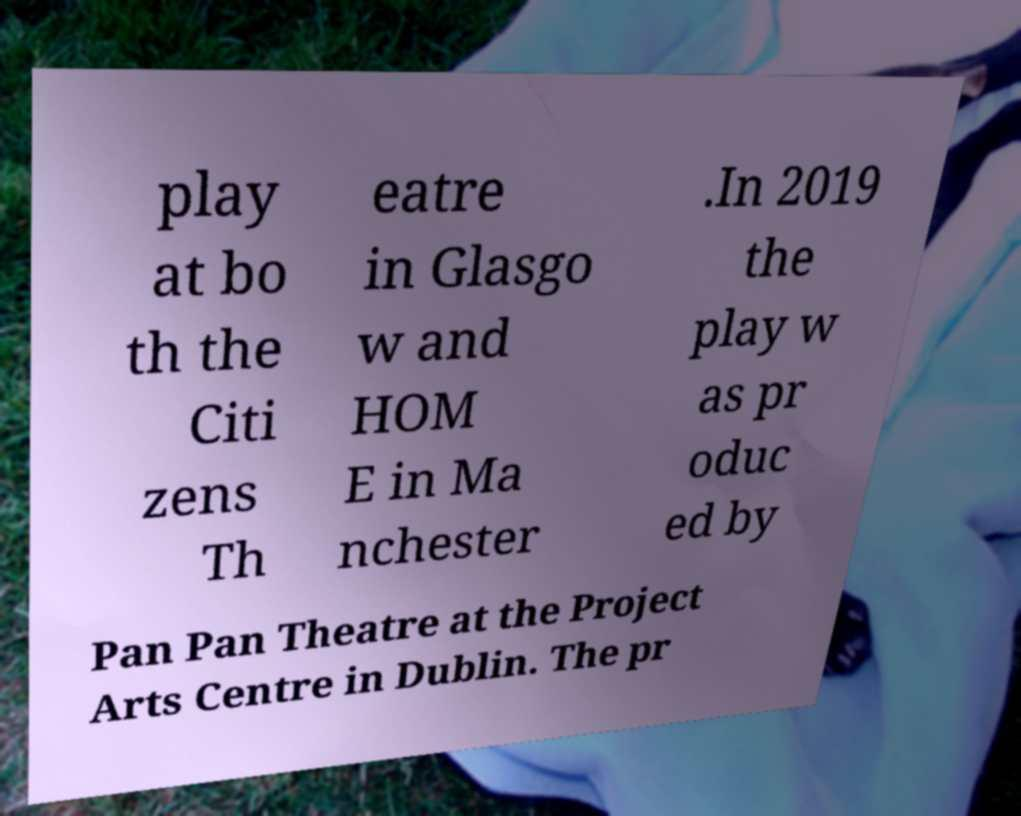Please read and relay the text visible in this image. What does it say? play at bo th the Citi zens Th eatre in Glasgo w and HOM E in Ma nchester .In 2019 the play w as pr oduc ed by Pan Pan Theatre at the Project Arts Centre in Dublin. The pr 